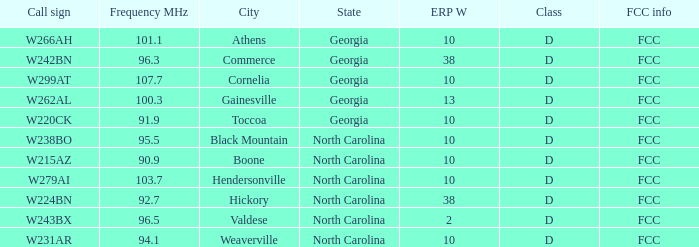What class is the city of black mountain, north carolina? D. 